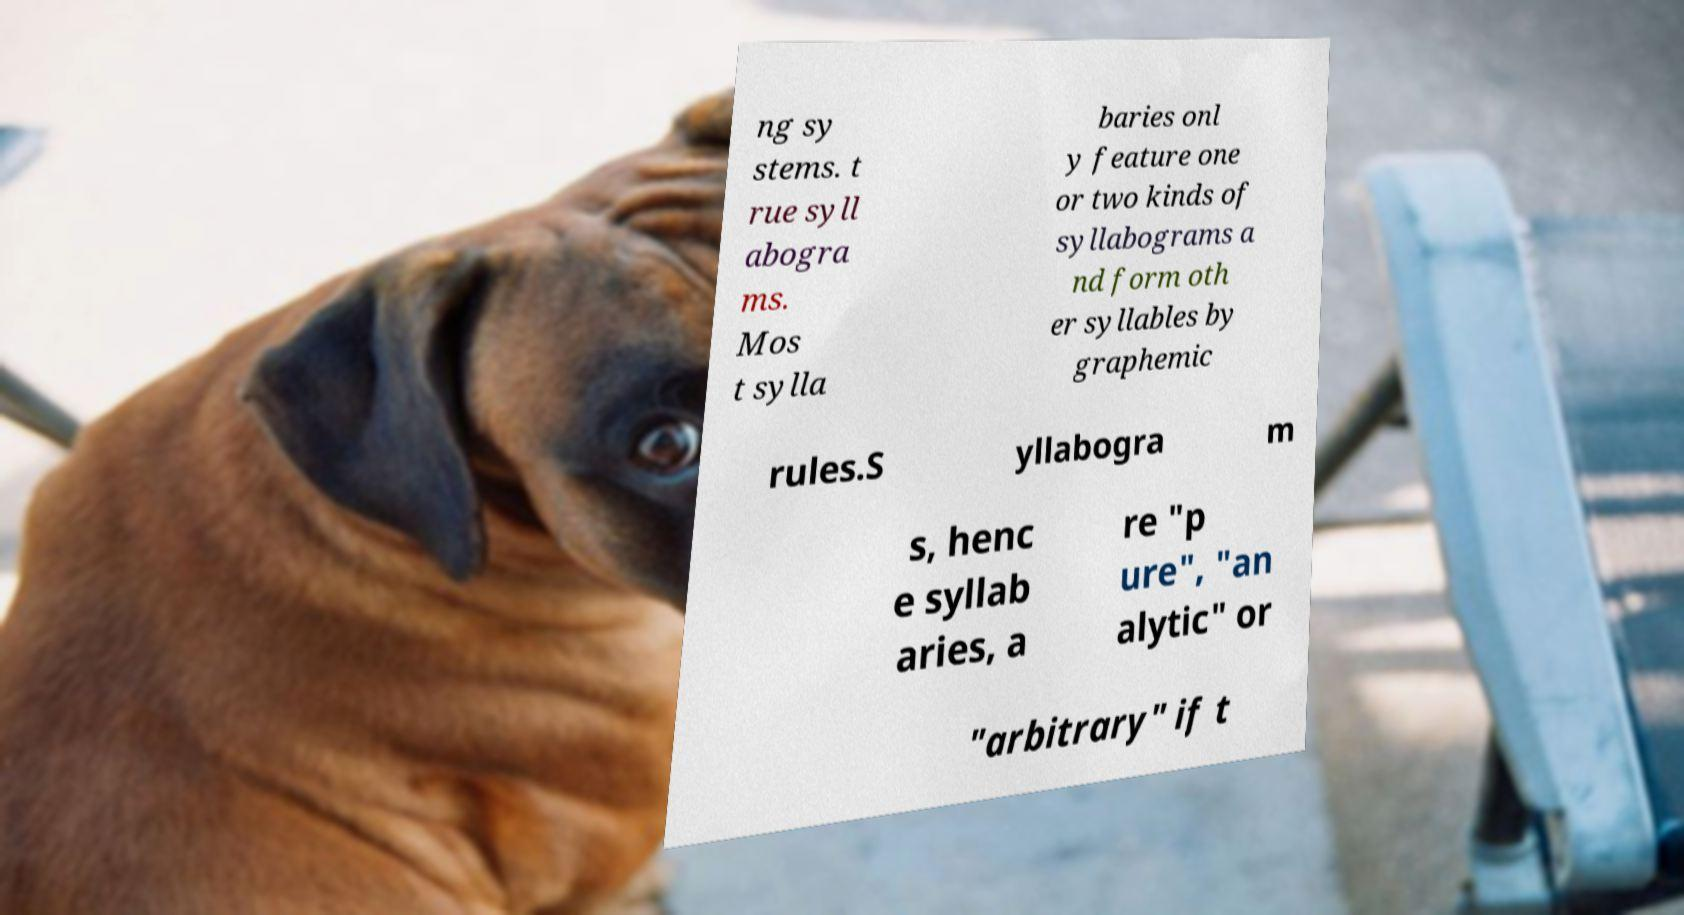Could you assist in decoding the text presented in this image and type it out clearly? ng sy stems. t rue syll abogra ms. Mos t sylla baries onl y feature one or two kinds of syllabograms a nd form oth er syllables by graphemic rules.S yllabogra m s, henc e syllab aries, a re "p ure", "an alytic" or "arbitrary" if t 